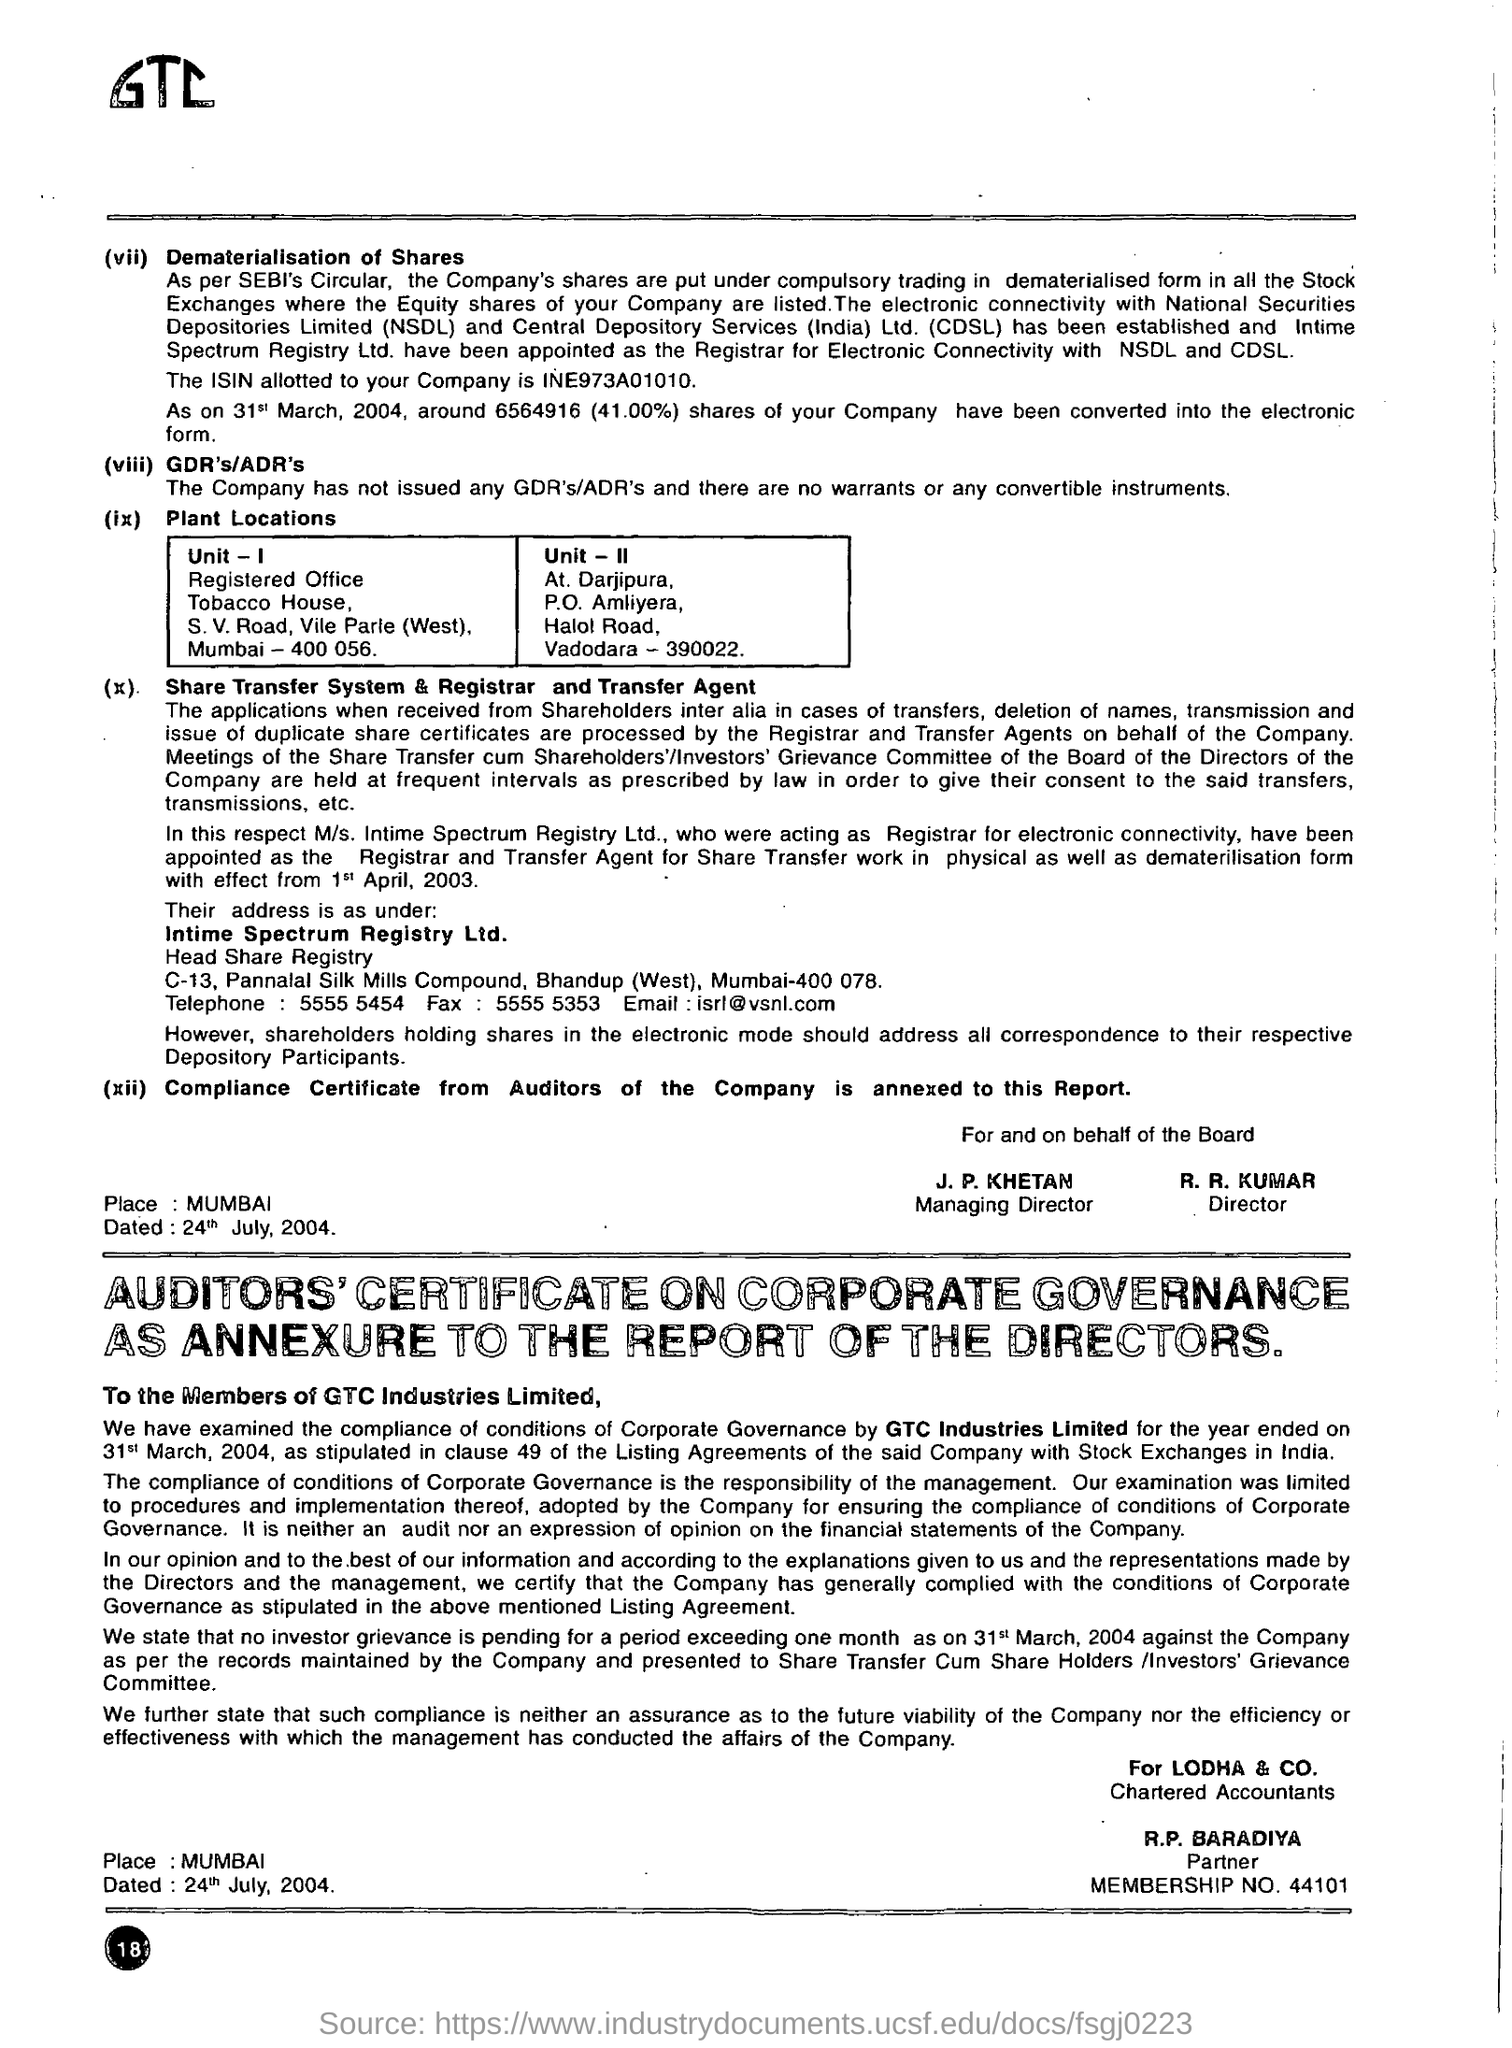What is the membership number of R.P. BARADIYA?
Make the answer very short. 44101. What is the name of the company?
Provide a short and direct response. Gtc industries limited. 